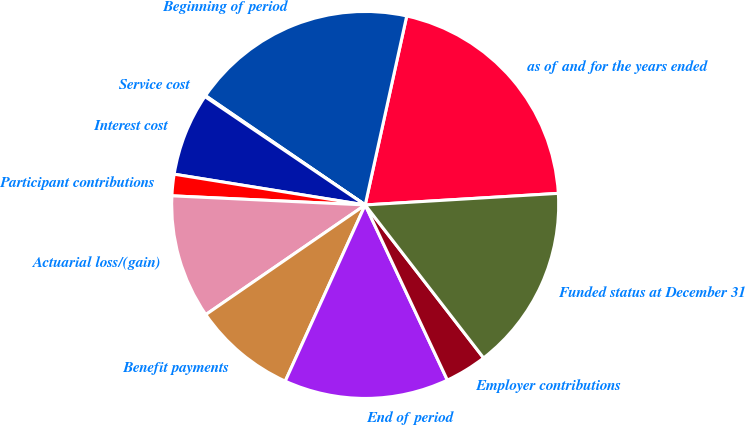Convert chart. <chart><loc_0><loc_0><loc_500><loc_500><pie_chart><fcel>as of and for the years ended<fcel>Beginning of period<fcel>Service cost<fcel>Interest cost<fcel>Participant contributions<fcel>Actuarial loss/(gain)<fcel>Benefit payments<fcel>End of period<fcel>Employer contributions<fcel>Funded status at December 31<nl><fcel>20.6%<fcel>18.89%<fcel>0.09%<fcel>6.92%<fcel>1.79%<fcel>10.34%<fcel>8.63%<fcel>13.76%<fcel>3.5%<fcel>15.47%<nl></chart> 